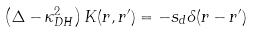Convert formula to latex. <formula><loc_0><loc_0><loc_500><loc_500>\left ( \Delta - \kappa _ { D H } ^ { 2 } \right ) K ( r , r ^ { \prime } ) = - s _ { d } \delta ( r - r ^ { \prime } )</formula> 